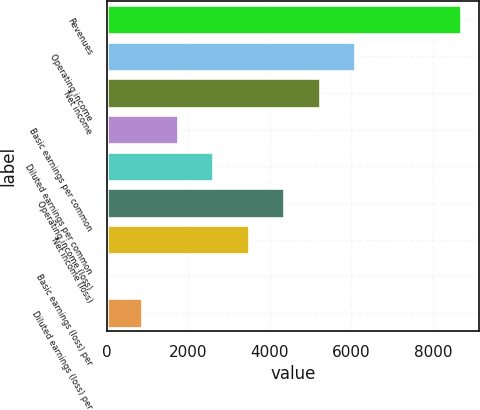<chart> <loc_0><loc_0><loc_500><loc_500><bar_chart><fcel>Revenues<fcel>Operating income<fcel>Net income<fcel>Basic earnings per common<fcel>Diluted earnings per common<fcel>Operating income (loss)<fcel>Net income (loss)<fcel>Basic earnings (loss) per<fcel>Diluted earnings (loss) per<nl><fcel>8701<fcel>6090.8<fcel>5220.73<fcel>1740.45<fcel>2610.52<fcel>4350.66<fcel>3480.59<fcel>0.31<fcel>870.38<nl></chart> 